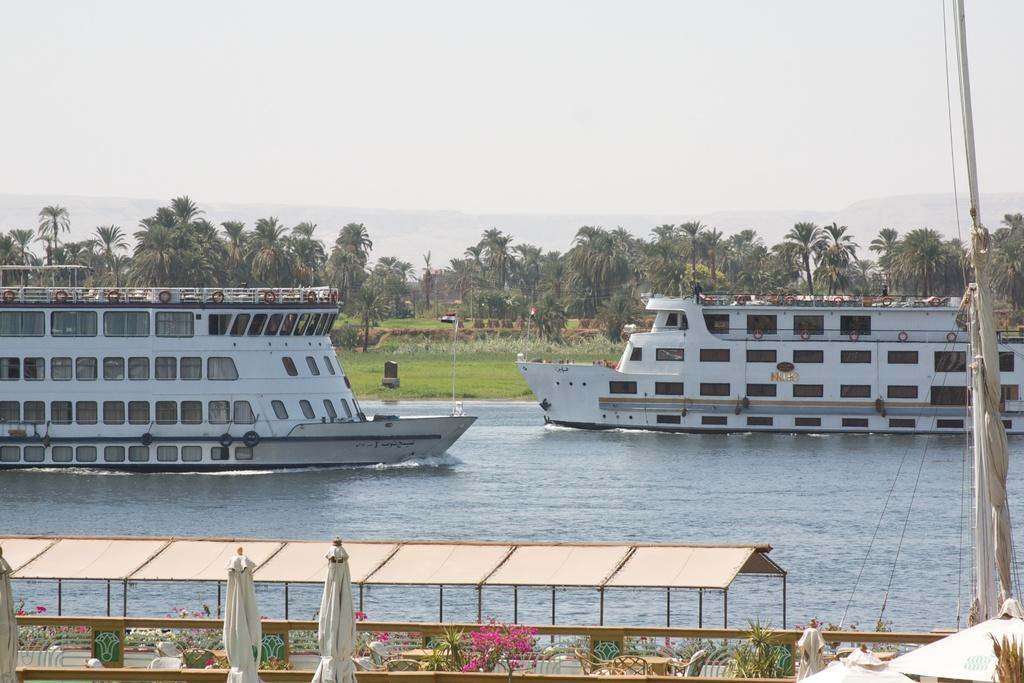How would you summarize this image in a sentence or two? In this picture there are ships on the right and left side of the image, on the water and there are umbrellas, flowers and a boundary at the bottom side of the image and there is greenery in the background area of the image. 